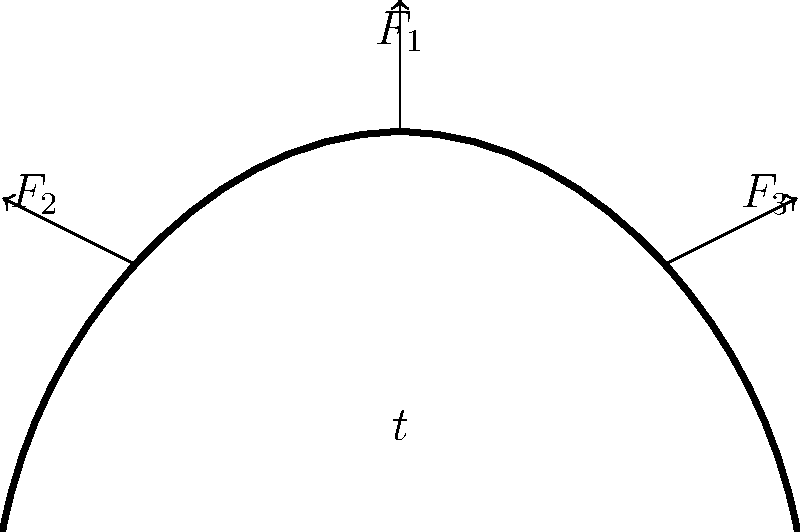A new combat helmet design is being evaluated for stress distribution. The helmet shell, made of advanced composite material, has a thickness of $t = 10$ mm. Three point loads are applied: a vertical force $F_1 = 2000$ N at the top, and two lateral forces $F_2 = F_3 = 1000$ N on each side. If the maximum allowable stress for the material is $\sigma_{max} = 200$ MPa, determine the factor of safety for this helmet design. Let's approach this step-by-step:

1) First, we need to calculate the total force acting on the helmet:
   $F_{total} = \sqrt{F_1^2 + F_2^2 + F_3^2}$
   $F_{total} = \sqrt{2000^2 + 1000^2 + 1000^2} = 2449.5$ N

2) Next, we need to estimate the cross-sectional area of the helmet. Assuming a circular cross-section with an average diameter of 20 cm:
   $A = \pi d t = \pi \times 0.2 \times 0.01 = 0.00628$ m²

3) Now we can calculate the average stress:
   $\sigma_{avg} = \frac{F_{total}}{A} = \frac{2449.5}{0.00628} = 390,047$ Pa or 390.05 MPa

4) The factor of safety (FOS) is the ratio of the maximum allowable stress to the actual stress:
   $FOS = \frac{\sigma_{max}}{\sigma_{avg}} = \frac{200}{390.05} = 0.51$

5) Since the FOS is less than 1, this design does not meet the safety requirements. The helmet needs to be redesigned to reduce stress, possibly by increasing the thickness or using a stronger material.
Answer: 0.51 